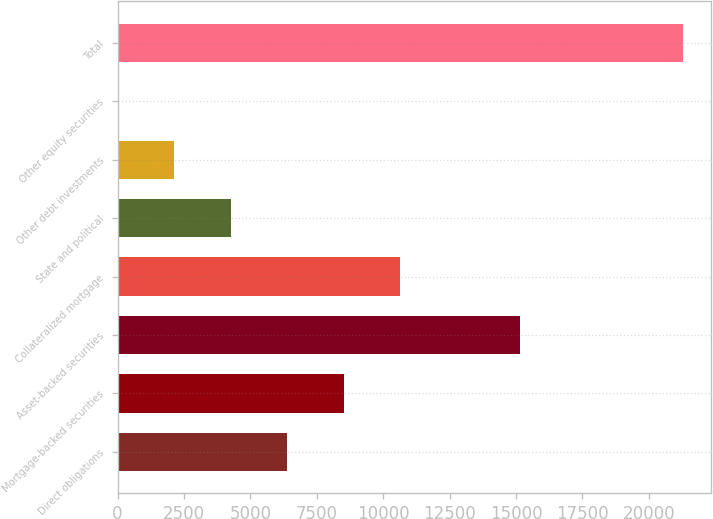<chart> <loc_0><loc_0><loc_500><loc_500><bar_chart><fcel>Direct obligations<fcel>Mortgage-backed securities<fcel>Asset-backed securities<fcel>Collateralized mortgage<fcel>State and political<fcel>Other debt investments<fcel>Other equity securities<fcel>Total<nl><fcel>6392.3<fcel>8519.4<fcel>15135<fcel>10646.5<fcel>4265.2<fcel>2138.1<fcel>11<fcel>21282<nl></chart> 